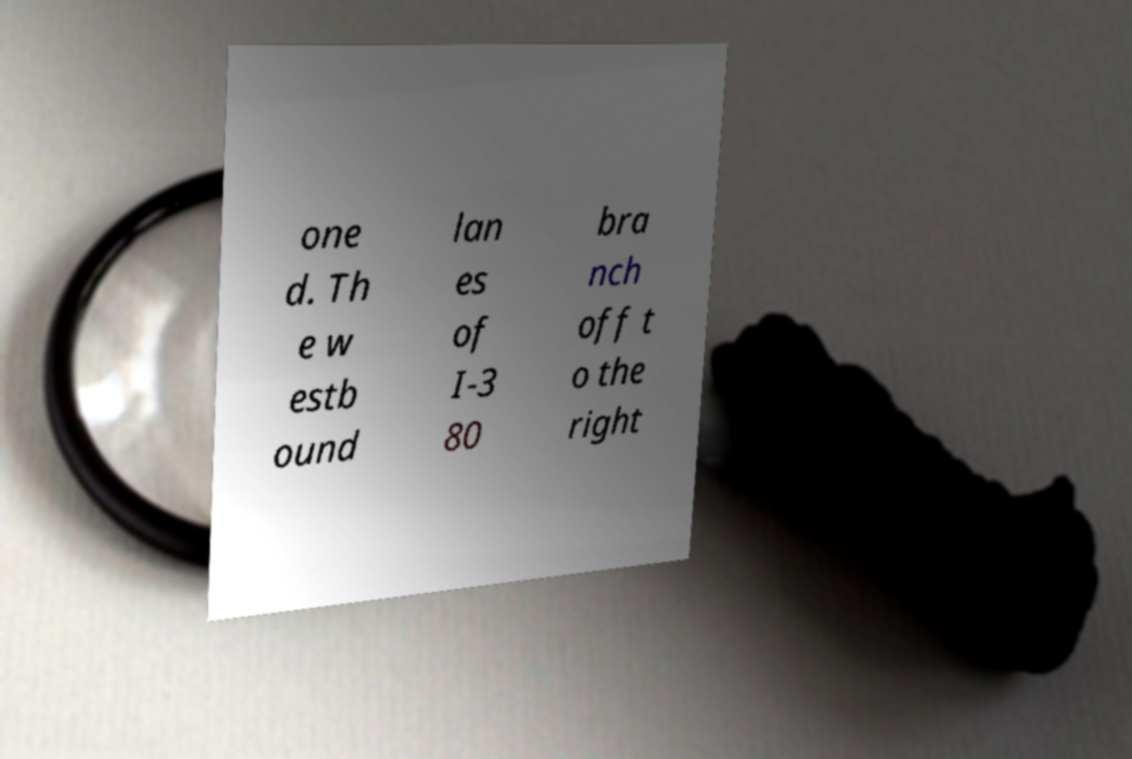Please identify and transcribe the text found in this image. one d. Th e w estb ound lan es of I-3 80 bra nch off t o the right 